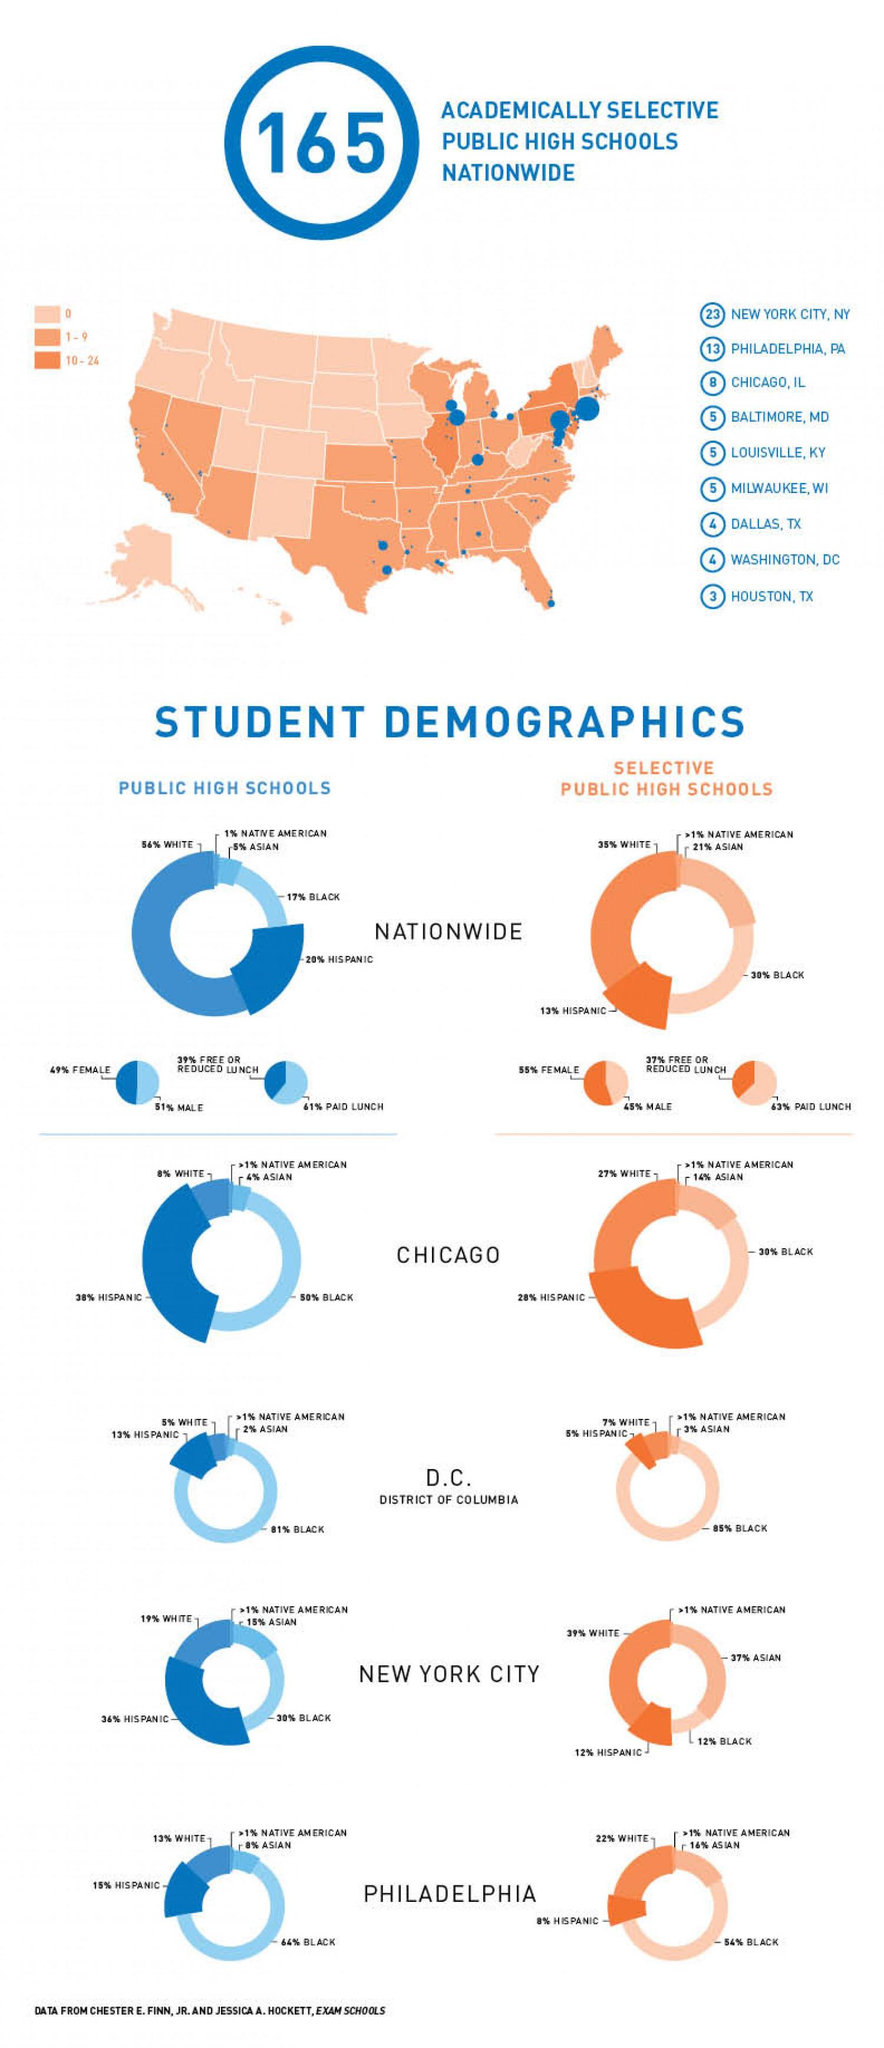Identify some key points in this picture. According to nationwide public school statistics, 61% of students are required to pay for their lunch. Asian students are the second largest community in selective public high schools in New York City. The Native American group is the minority in nationwide public high schools. According to a nationwide survey of selective public high schools, 55% of the students are female. There are three academically selective public high schools located in Houston. 